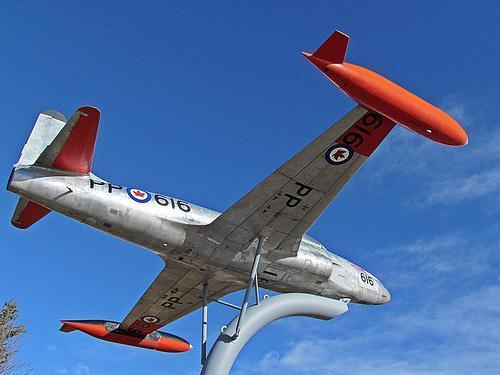How many planes are visible?
Give a very brief answer. 1. 